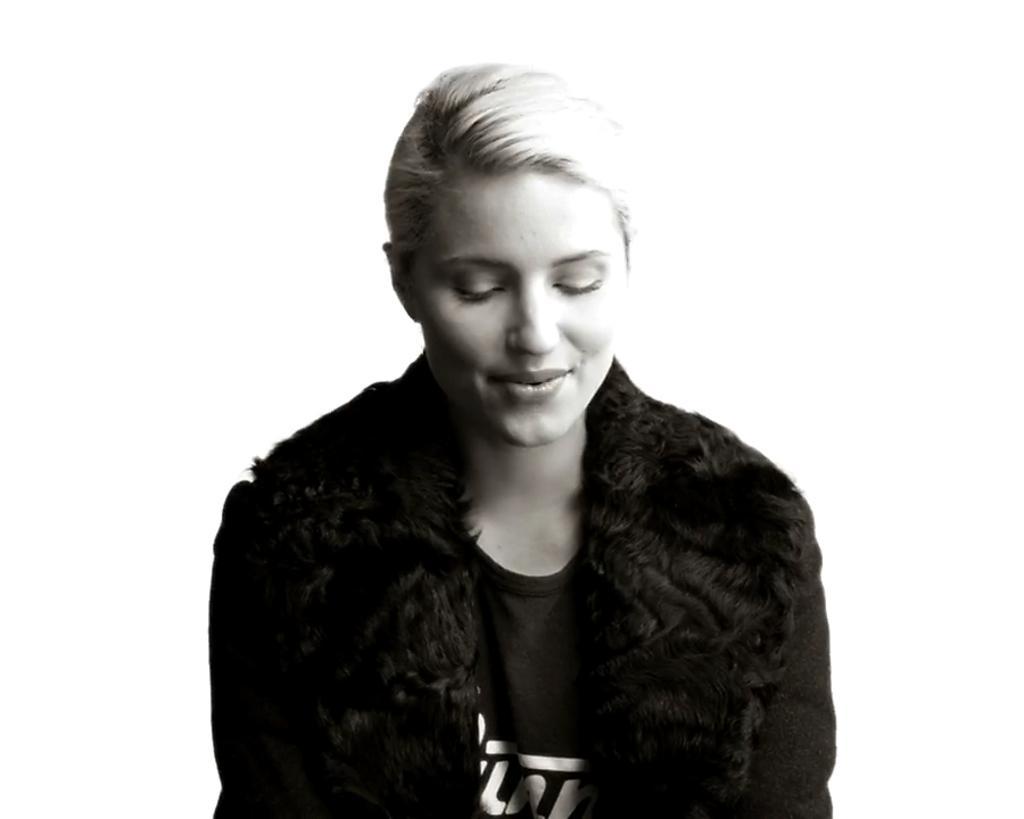Describe this image in one or two sentences. In the image in the center we can see one woman sitting and she is smiling,which we can see on her face. And she is in black color jacket. 